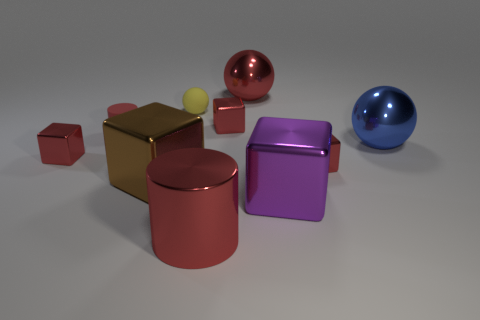The sphere that is the same color as the big metallic cylinder is what size?
Offer a very short reply. Large. Is there another cylinder that has the same color as the rubber cylinder?
Give a very brief answer. Yes. The rubber object that is the same color as the shiny cylinder is what shape?
Make the answer very short. Cylinder. The matte ball is what color?
Keep it short and to the point. Yellow. How big is the red metal cube that is on the left side of the small red matte thing?
Ensure brevity in your answer.  Small. How many red metal cubes are on the left side of the cylinder that is in front of the red cube that is on the left side of the tiny red matte thing?
Make the answer very short. 1. There is a big metallic cube that is right of the big red shiny thing that is to the right of the shiny cylinder; what is its color?
Make the answer very short. Purple. Is there another object that has the same size as the brown shiny object?
Offer a very short reply. Yes. There is a red cylinder that is behind the small red block that is right of the big thing behind the small yellow object; what is its material?
Provide a succinct answer. Rubber. There is a large red object on the right side of the red shiny cylinder; how many red metal cubes are to the right of it?
Your answer should be very brief. 1. 